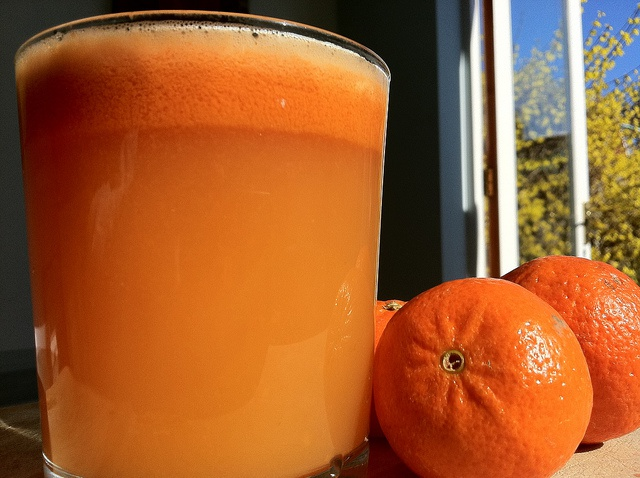Describe the objects in this image and their specific colors. I can see dining table in red, black, maroon, and brown tones, cup in black, red, brown, maroon, and orange tones, orange in black, red, brown, orange, and maroon tones, and dining table in black, maroon, and gray tones in this image. 